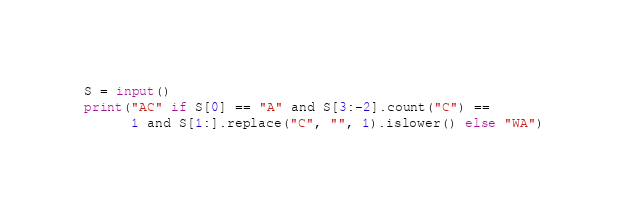<code> <loc_0><loc_0><loc_500><loc_500><_Python_>S = input()
print("AC" if S[0] == "A" and S[3:-2].count("C") ==
      1 and S[1:].replace("C", "", 1).islower() else "WA")
</code> 